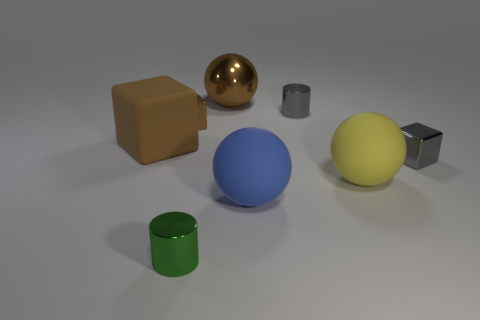The brown metal thing that is in front of the brown metallic sphere has what shape?
Your response must be concise. Cube. Is the number of rubber objects greater than the number of large rubber balls?
Provide a succinct answer. Yes. Does the tiny cylinder that is behind the large yellow sphere have the same color as the big shiny ball?
Offer a very short reply. No. What number of objects are large objects behind the brown rubber block or shiny cylinders right of the green cylinder?
Provide a succinct answer. 2. What number of tiny objects are both to the right of the tiny brown metal cube and behind the big yellow matte ball?
Keep it short and to the point. 2. Do the small brown object and the small gray cylinder have the same material?
Your answer should be compact. Yes. What is the shape of the metallic object in front of the large sphere on the right side of the small cylinder to the right of the brown shiny sphere?
Your answer should be compact. Cylinder. What material is the big object that is right of the large cube and behind the yellow ball?
Your response must be concise. Metal. What color is the shiny ball that is behind the gray metallic thing behind the metallic cube that is on the right side of the big metallic sphere?
Your answer should be very brief. Brown. What number of purple objects are either small metal cubes or large shiny things?
Keep it short and to the point. 0. 